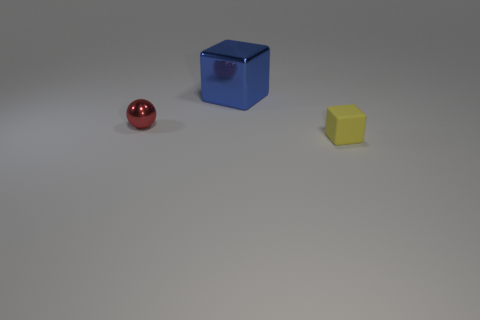Add 3 cubes. How many objects exist? 6 Subtract all cubes. How many objects are left? 1 Subtract all small spheres. Subtract all big green matte cubes. How many objects are left? 2 Add 1 yellow rubber things. How many yellow rubber things are left? 2 Add 1 small blue shiny objects. How many small blue shiny objects exist? 1 Subtract 0 red blocks. How many objects are left? 3 